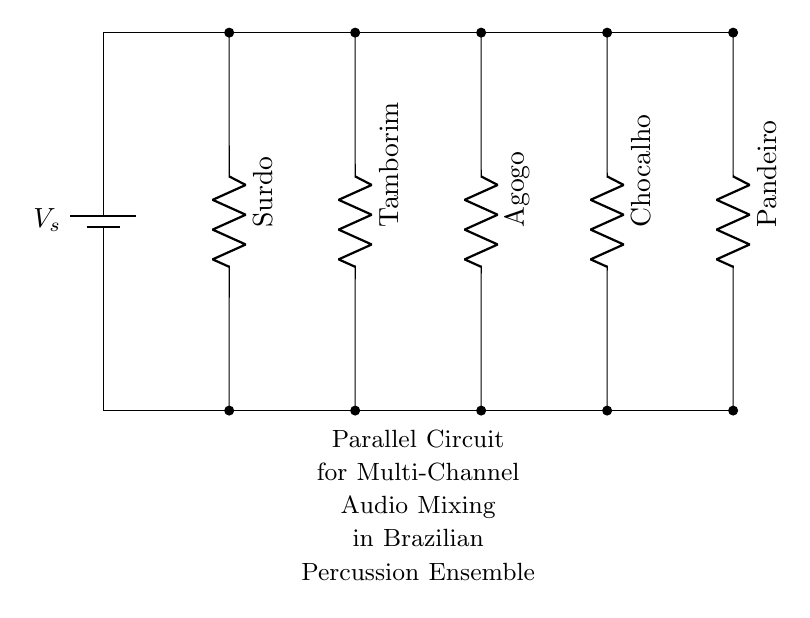What is the total number of components in this circuit? The circuit diagram shows five resistors (each representing a different Brazilian percussion instrument) connected in parallel. Counting them gives a total of five components.
Answer: five Which instrument is represented on the leftmost side of the circuit? The leftmost component in the circuit diagram is labeled "Surdo," which is a type of percussion instrument commonly used in Brazilian music.
Answer: Surdo What type of circuit is depicted in this diagram? The circuit is a parallel circuit, as indicated by the arrangement of the components connected across the same voltage source without being in series.
Answer: Parallel How many channels are there in the audio mixing circuit? Each resistor in the diagram corresponds to a different channel for audio mixing. There are five resistors, signifying five channels.
Answer: five What is the role of the battery in the circuit? The battery provides the voltage source for the circuit, allowing each connected instrument to receive power and produce sound.
Answer: Voltage source Which instrument is represented by the rightmost component? The rightmost component in the circuit diagram is labeled "Pandeiro," which is another traditional Brazilian percussion instrument.
Answer: Pandeiro Are all components connected in series or parallel? All components are connected in parallel, as indicated by the branching connections allowing for multiple paths for current.
Answer: Parallel 